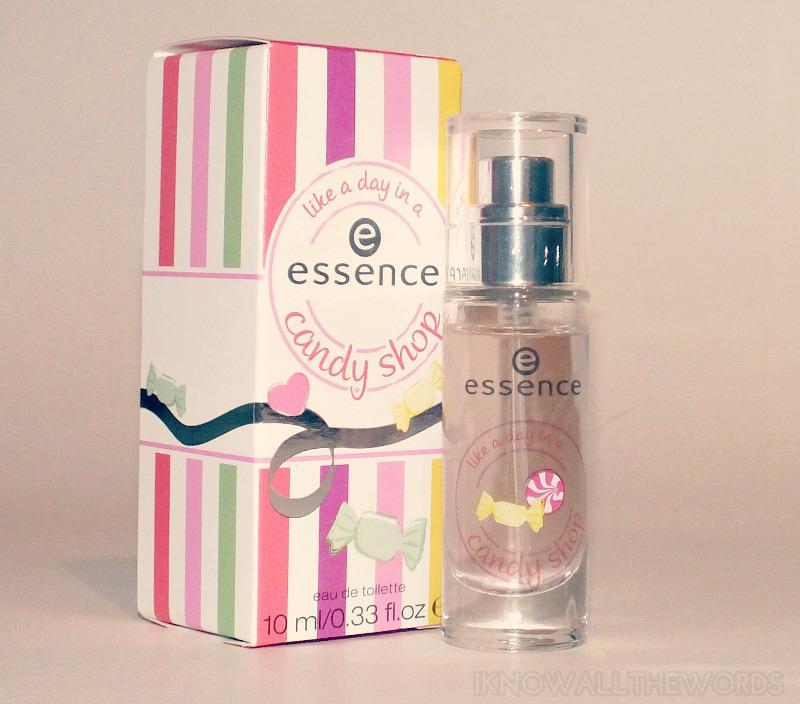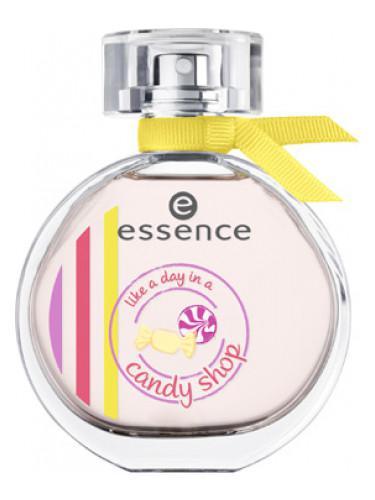The first image is the image on the left, the second image is the image on the right. For the images shown, is this caption "Both images show a circular perfume bottle next to a candy-striped box." true? Answer yes or no. No. 